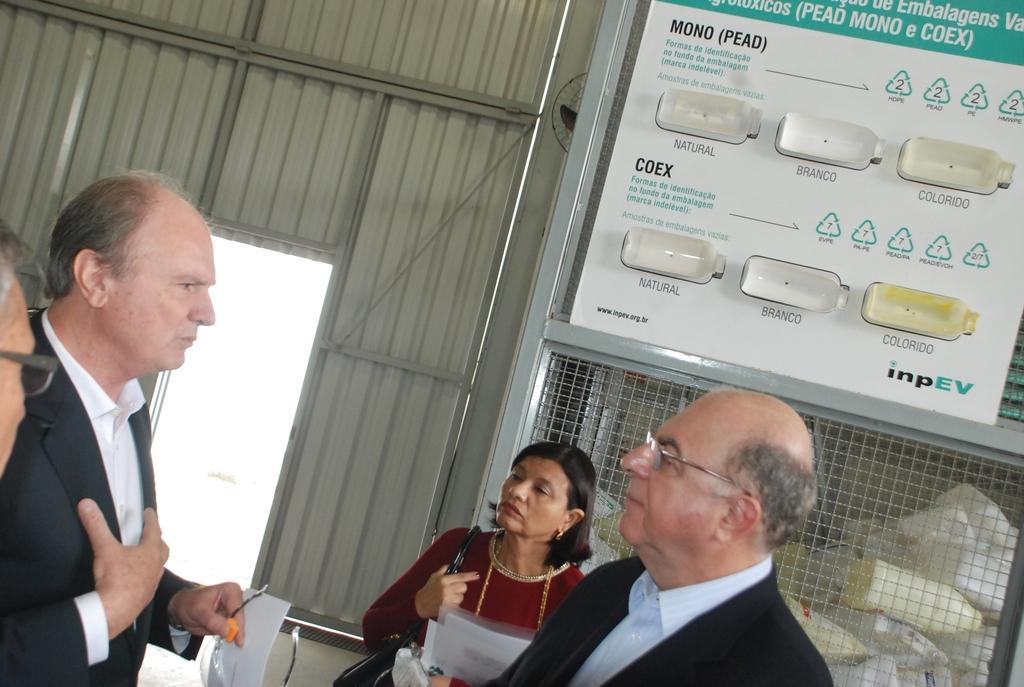Please provide a concise description of this image. At the bottom of the image we can see two persons are standing, a lady is carrying bag and holding papers. On the left side of the image we can see two persons are standing and one man is holding paper, spectacles. In the background of the image we can see boards, mesh, some objects, wall, door, fan. 